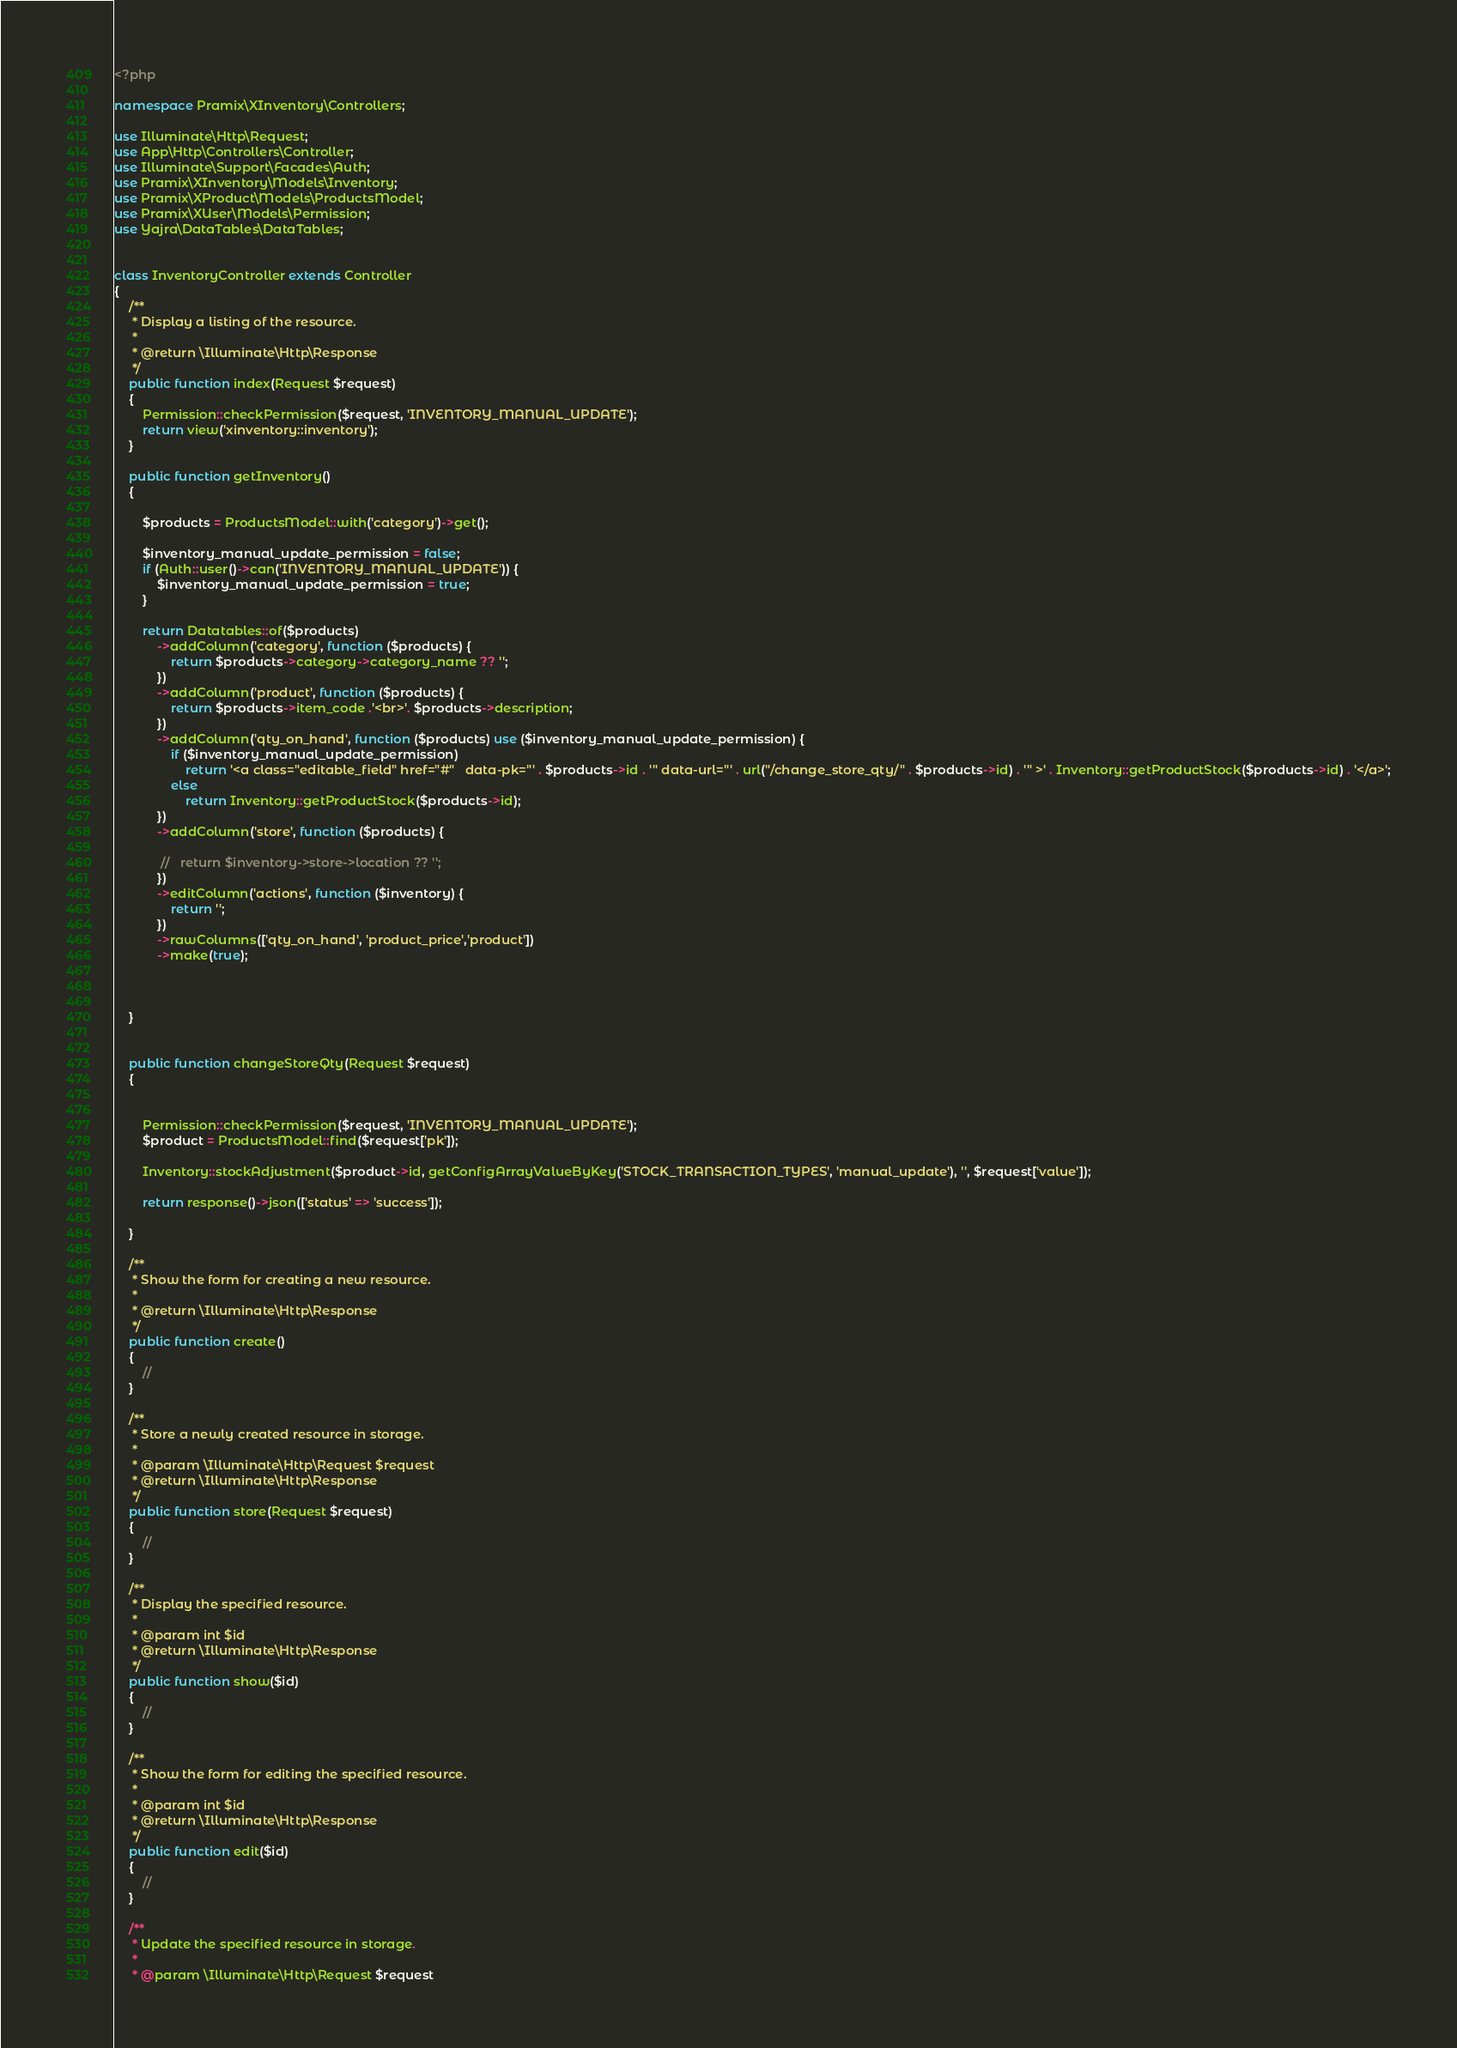Convert code to text. <code><loc_0><loc_0><loc_500><loc_500><_PHP_><?php

namespace Pramix\XInventory\Controllers;

use Illuminate\Http\Request;
use App\Http\Controllers\Controller;
use Illuminate\Support\Facades\Auth;
use Pramix\XInventory\Models\Inventory;
use Pramix\XProduct\Models\ProductsModel;
use Pramix\XUser\Models\Permission;
use Yajra\DataTables\DataTables;


class InventoryController extends Controller
{
    /**
     * Display a listing of the resource.
     *
     * @return \Illuminate\Http\Response
     */
    public function index(Request $request)
    {
        Permission::checkPermission($request, 'INVENTORY_MANUAL_UPDATE');
        return view('xinventory::inventory');
    }

    public function getInventory()
    {

        $products = ProductsModel::with('category')->get();

        $inventory_manual_update_permission = false;
        if (Auth::user()->can('INVENTORY_MANUAL_UPDATE')) {
            $inventory_manual_update_permission = true;
        }

        return Datatables::of($products)
            ->addColumn('category', function ($products) {
                return $products->category->category_name ?? '';
            })
            ->addColumn('product', function ($products) {
                return $products->item_code .'<br>'. $products->description;
            })
            ->addColumn('qty_on_hand', function ($products) use ($inventory_manual_update_permission) {
                if ($inventory_manual_update_permission)
                    return '<a class="editable_field" href="#"   data-pk="' . $products->id . '" data-url="' . url("/change_store_qty/" . $products->id) . '" >' . Inventory::getProductStock($products->id) . '</a>';
                else
                    return Inventory::getProductStock($products->id);
            })
            ->addColumn('store', function ($products) {

             //   return $inventory->store->location ?? '';
            })
            ->editColumn('actions', function ($inventory) {
                return '';
            })
            ->rawColumns(['qty_on_hand', 'product_price','product'])
            ->make(true);



    }


    public function changeStoreQty(Request $request)
    {


        Permission::checkPermission($request, 'INVENTORY_MANUAL_UPDATE');
        $product = ProductsModel::find($request['pk']);

        Inventory::stockAdjustment($product->id, getConfigArrayValueByKey('STOCK_TRANSACTION_TYPES', 'manual_update'), '', $request['value']);

        return response()->json(['status' => 'success']);

    }

    /**
     * Show the form for creating a new resource.
     *
     * @return \Illuminate\Http\Response
     */
    public function create()
    {
        //
    }

    /**
     * Store a newly created resource in storage.
     *
     * @param \Illuminate\Http\Request $request
     * @return \Illuminate\Http\Response
     */
    public function store(Request $request)
    {
        //
    }

    /**
     * Display the specified resource.
     *
     * @param int $id
     * @return \Illuminate\Http\Response
     */
    public function show($id)
    {
        //
    }

    /**
     * Show the form for editing the specified resource.
     *
     * @param int $id
     * @return \Illuminate\Http\Response
     */
    public function edit($id)
    {
        //
    }

    /**
     * Update the specified resource in storage.
     *
     * @param \Illuminate\Http\Request $request</code> 